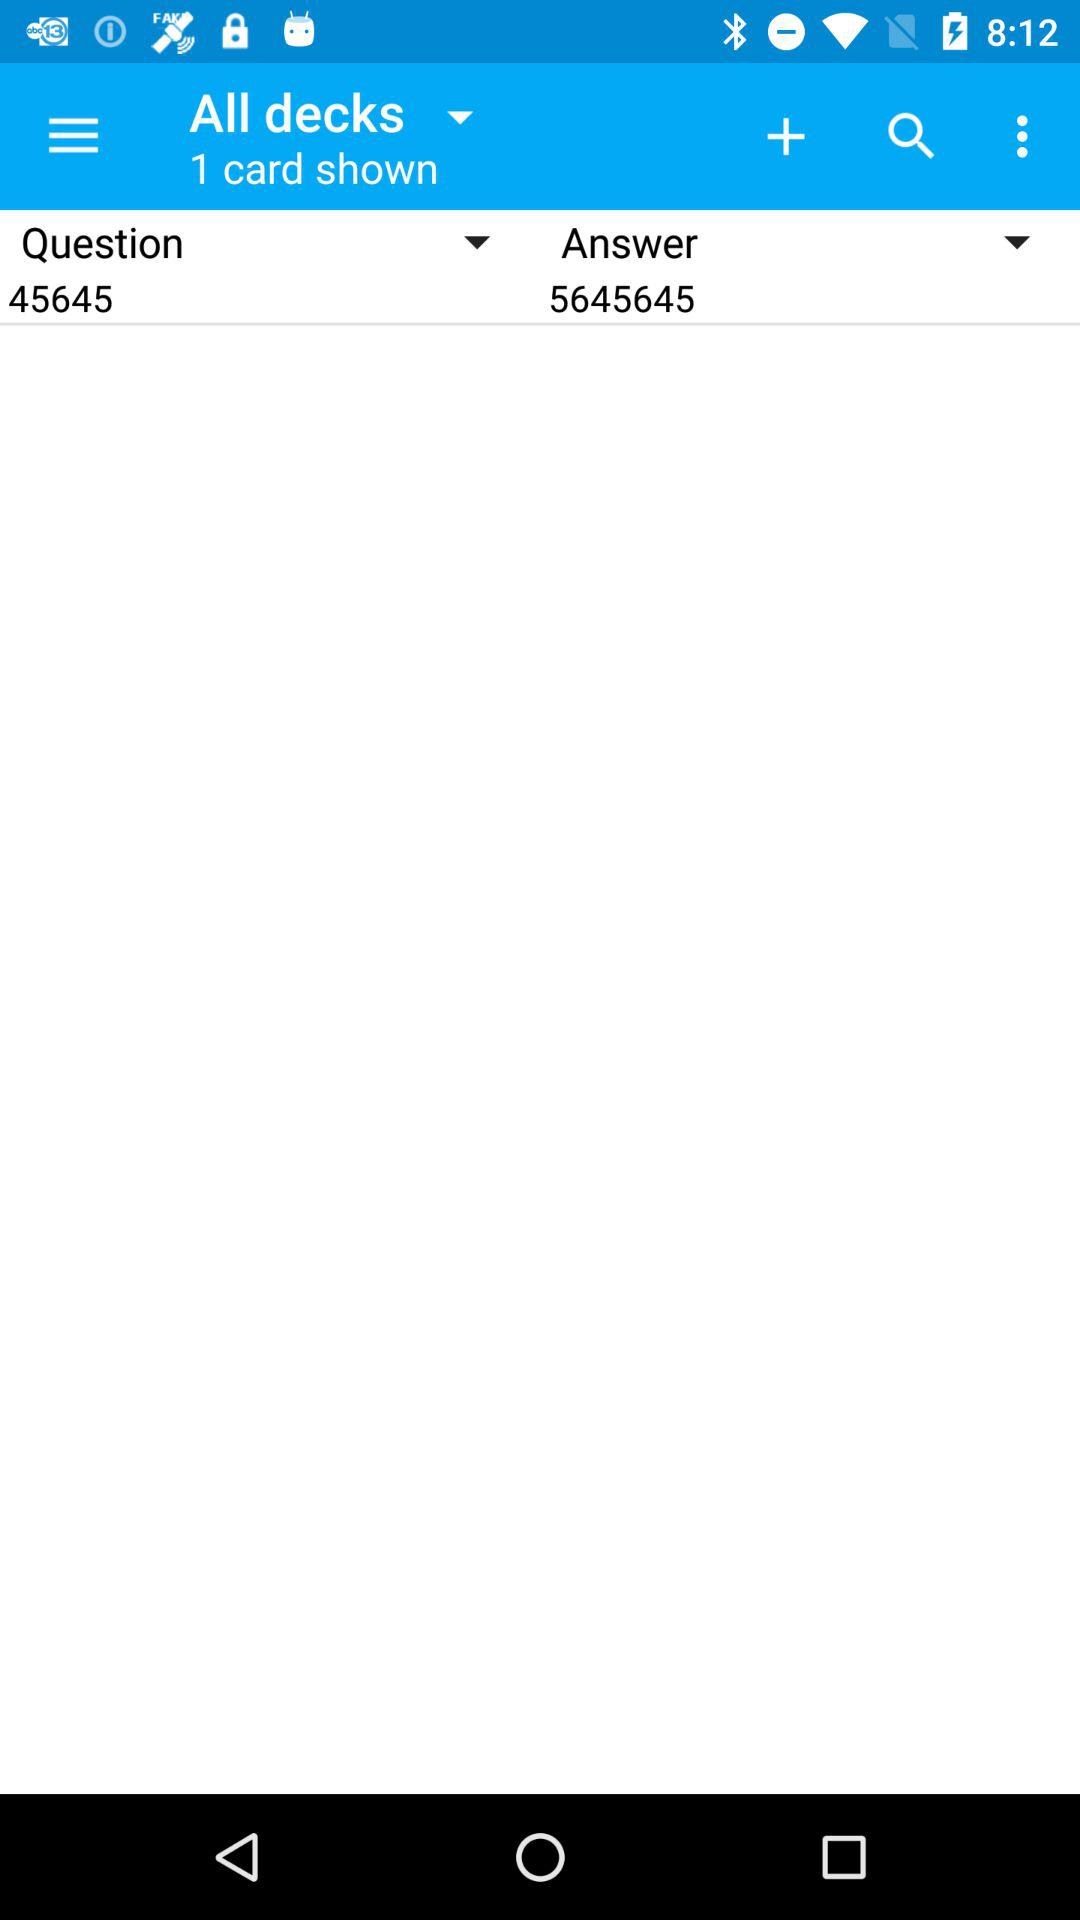What is the question number? The question number is 45645. 